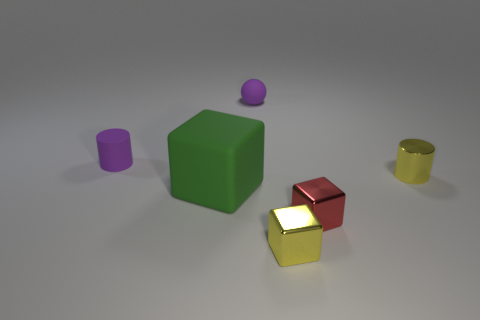Are there any other things that are the same size as the green rubber cube?
Give a very brief answer. No. There is a ball that is the same color as the rubber cylinder; what material is it?
Ensure brevity in your answer.  Rubber. There is a tiny object that is both behind the big thing and on the right side of the yellow shiny block; what shape is it?
Offer a very short reply. Cylinder. What is the size of the matte block on the left side of the small yellow thing that is right of the yellow metallic cube?
Your answer should be compact. Large. How many other things are there of the same color as the tiny sphere?
Your response must be concise. 1. What is the material of the red block?
Ensure brevity in your answer.  Metal. Are there any cyan metal cylinders?
Provide a succinct answer. No. Are there an equal number of yellow shiny blocks in front of the yellow metal cylinder and rubber cylinders?
Your answer should be very brief. Yes. Is there any other thing that is made of the same material as the small ball?
Your response must be concise. Yes. How many large objects are matte objects or purple cylinders?
Make the answer very short. 1. 